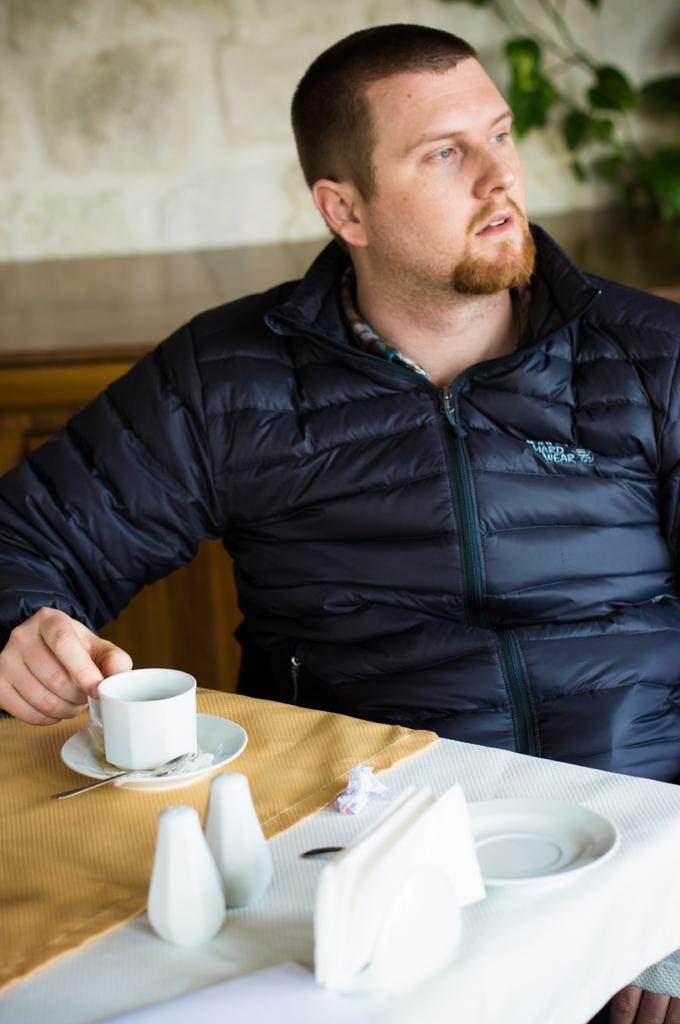What is the man in the image doing? The man is sitting on a chair in the image. What can be seen on the table in the image? There is a cup, a saucer, and tissues on the table in the image. Can you see any mountains in the image? There are no mountains present in the image. What type of plane is flying over the man in the image? There is no plane visible in the image. 